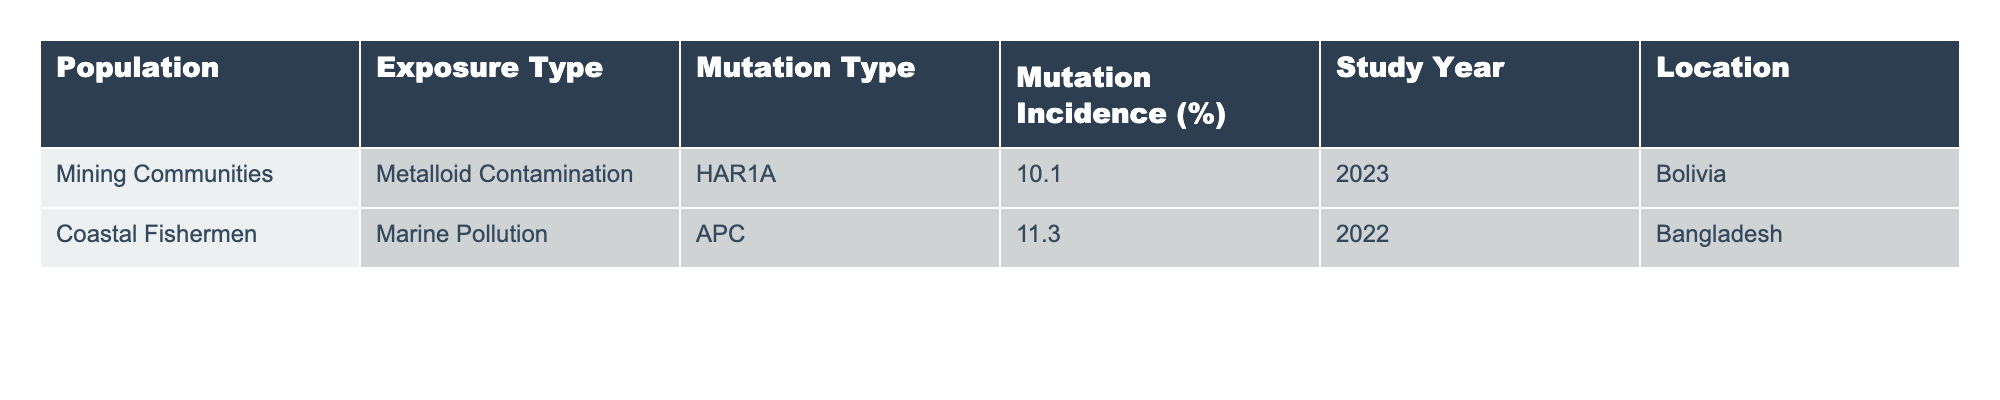What is the mutation type reported in mining communities? The table lists the mutation type associated with mining communities, which is HAR1A.
Answer: HAR1A What is the mutation incidence percentage for coastal fishermen? The table shows that the mutation incidence for coastal fishermen is 11.3%.
Answer: 11.3% Which population has the highest mutation incidence? Comparing the mutation incidence percentages of both populations, mining communities have 10.1% while coastal fishermen have 11.3%, making coastal fishermen the group with the highest incidence.
Answer: Coastal fishermen Was the study for mining communities conducted in 2022? The table indicates that the study year for mining communities is 2023, not 2022.
Answer: No Calculate the average mutation incidence for the populations listed in the table. The table shows mutation incidences of 10.1% and 11.3%. To find the average, sum them: (10.1 + 11.3) = 21.4, then divide by 2 (number of populations): 21.4 / 2 = 10.7%.
Answer: 10.7% Is there a correlation between exposure type and mutation incidence in the table? The table features only two populations with differing exposure types and mutation incidences, making it difficult to draw a definitive correlation because there are insufficient data points to analyze trends.
Answer: No Which location has reported a mutation incidence of more than 10%? The table shows both populations have mutation incidences above 10%, with mining communities at 10.1% and coastal fishermen at 11.3%. Therefore, both locations qualify.
Answer: Both locations What specific environmental trigger is associated with mutation incidence in coastal fishermen? According to the table, the mutation in coastal fishermen is associated with marine pollution.
Answer: Marine pollution Which study year corresponds to the mutation incidence in coastal fishermen? The table indicates that the study year for coastal fishermen is 2022.
Answer: 2022 Compare the mutation incidence percentages of the two populations. The table shows mining communities with 10.1% and coastal fishermen with 11.3%. Therefore, coastal fishermen's mutation incidence is 1.2% higher than that of mining communities.
Answer: 1.2% higher Which mutation type is linked to metalloid contamination? The table shows that HAR1A is the mutation type linked to metalloid contamination in mining communities.
Answer: HAR1A 